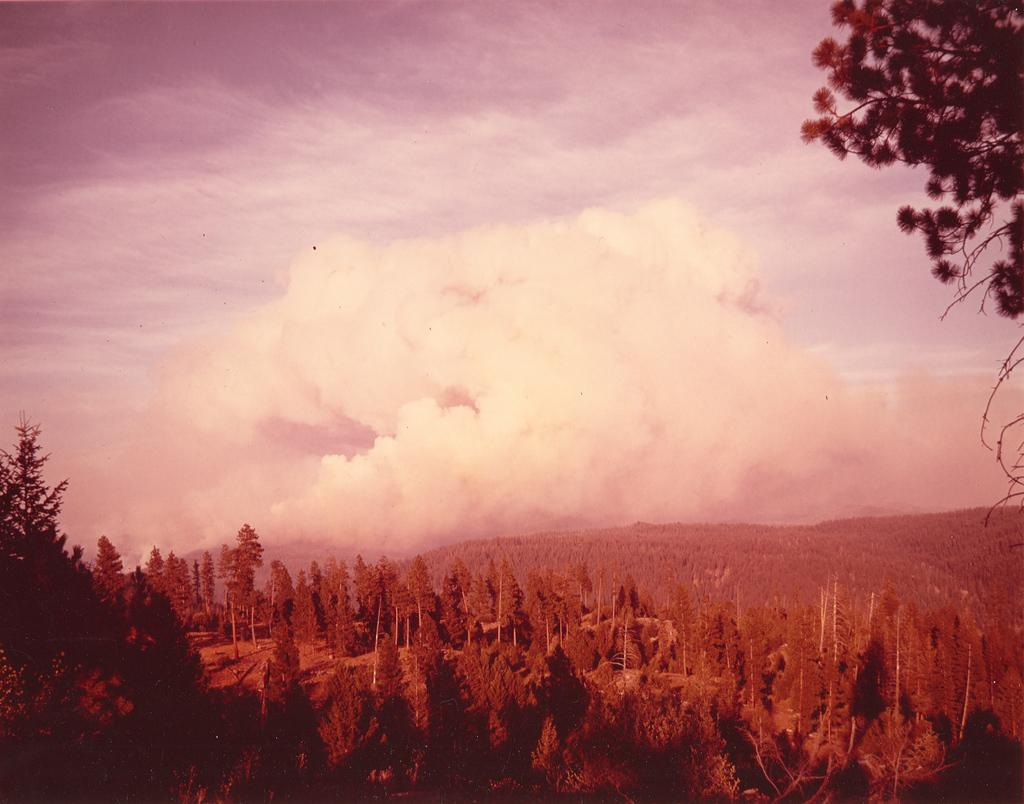What type of natural elements can be seen in the image? There are trees in the image. What atmospheric condition is present in the image? There is fog in the image. Can you describe any other objects in the image besides the trees? Yes, there are other objects in the image. What is visible at the top of the image? The sky is visible at the top of the image. Where is the tree located in the image? There appears to be a tree on the right side top of the image. What type of test is being conducted in the image? There is no indication of a test being conducted in the image. What kind of insurance policy is relevant to the objects in the image? There is no information about insurance policies in the image. 